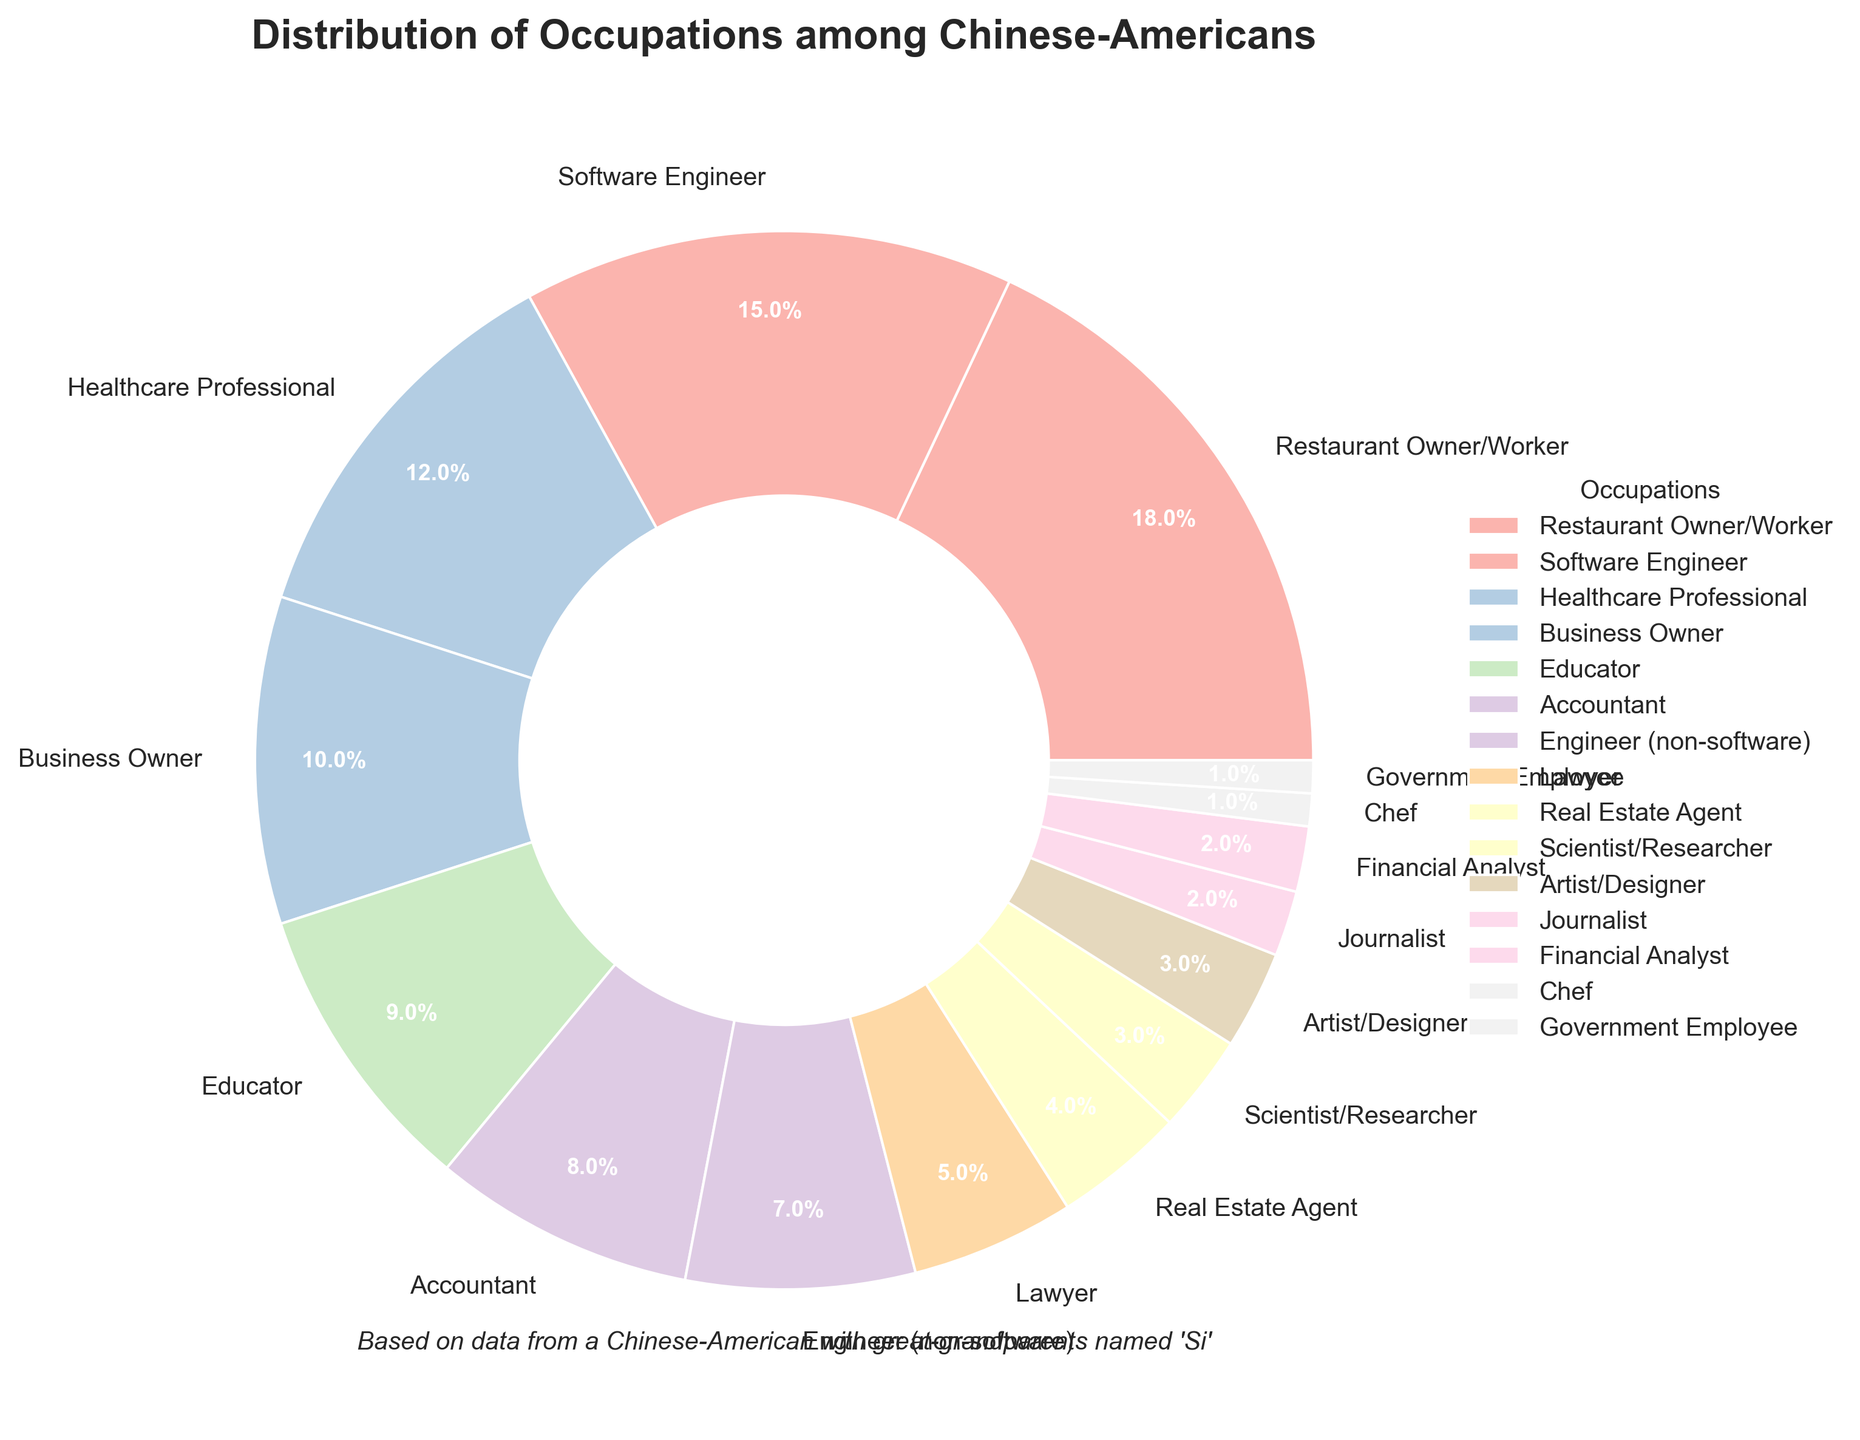Which occupation has the highest percentage? The pie chart shows that the segment for "Restaurant Owner/Worker" is the largest, indicating it has the highest percentage.
Answer: Restaurant Owner/Worker What's the combined percentage of Software Engineer and Healthcare Professional? Adding the percentages of Software Engineer (15%) and Healthcare Professional (12%) gives 15% + 12% = 27%.
Answer: 27% How does the percentage of Lawyers compare to that of Real Estate Agents? The pie chart shows the percentage for Lawyers is 5%, while that for Real Estate Agents is 4%. Thus, Lawyers have a slightly higher percentage than Real Estate Agents.
Answer: Lawyers have a higher percentage Which occupations have the smallest percentage? The smallest segments in the pie chart are for "Government Employee" and "Chef," each accounting for 1% of the distribution.
Answer: Government Employee and Chef What is the total percentage of artistic professions (Artist/Designer and Journalist)? Adding the percentages of Artist/Designer (3%) and Journalist (2%) gives 3% + 2% = 5%.
Answer: 5% Which three occupations have the highest percentages? The three largest segments in the pie chart are for "Restaurant Owner/Worker" (18%), "Software Engineer" (15%), and "Healthcare Professional" (12%).
Answer: Restaurant Owner/Worker, Software Engineer, Healthcare Professional What is the difference in percentage between Business Owners and Accountants? The pie chart shows Business Owners at 10% and Accountants at 8%. The difference is 10% - 8% = 2%.
Answer: 2% What is the visual appearance of the segment for "Restaurant Owner/Worker"? The segment for "Restaurant Owner/Worker" is the largest in the pie chart and is likely a prominent color from the pastel palette used.
Answer: Largest, prominent color What's the combined percentage for non-technical professions (e.g., Educator, Lawyer, Real Estate Agent)? Adding the percentages of Educator (9%), Lawyer (5%), and Real Estate Agent (4%) gives 9% + 5% + 4% = 18%.
Answer: 18% How many occupations are represented by less than 5% each? The pie chart shows that nine occupations have segments less than 5%: Real Estate Agent (4%), Artist/Designer (3%), Scientist/Researcher (3%), Financial Analyst (2%), Journalist (2%), Government Employee (1%), and Chef (1%).
Answer: 9 